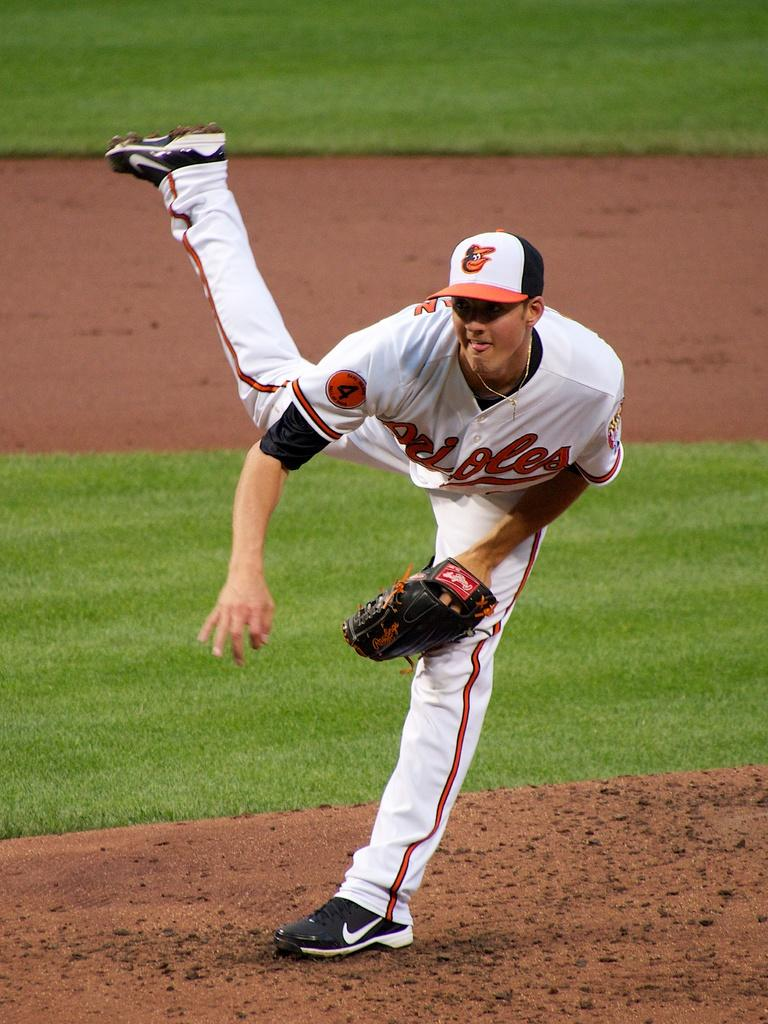<image>
Summarize the visual content of the image. baseball player number 4 wearing a hat with a bird on it 